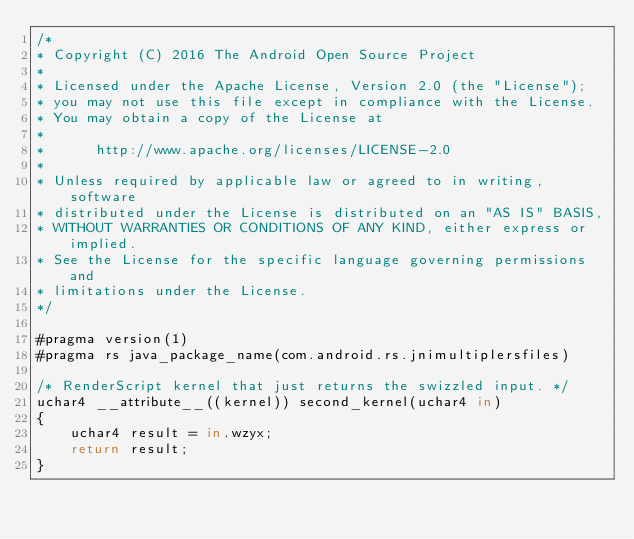Convert code to text. <code><loc_0><loc_0><loc_500><loc_500><_Rust_>/*
* Copyright (C) 2016 The Android Open Source Project
*
* Licensed under the Apache License, Version 2.0 (the "License");
* you may not use this file except in compliance with the License.
* You may obtain a copy of the License at
*
*      http://www.apache.org/licenses/LICENSE-2.0
*
* Unless required by applicable law or agreed to in writing, software
* distributed under the License is distributed on an "AS IS" BASIS,
* WITHOUT WARRANTIES OR CONDITIONS OF ANY KIND, either express or implied.
* See the License for the specific language governing permissions and
* limitations under the License.
*/

#pragma version(1)
#pragma rs java_package_name(com.android.rs.jnimultiplersfiles)

/* RenderScript kernel that just returns the swizzled input. */
uchar4 __attribute__((kernel)) second_kernel(uchar4 in)
{
    uchar4 result = in.wzyx;
    return result;
}
</code> 